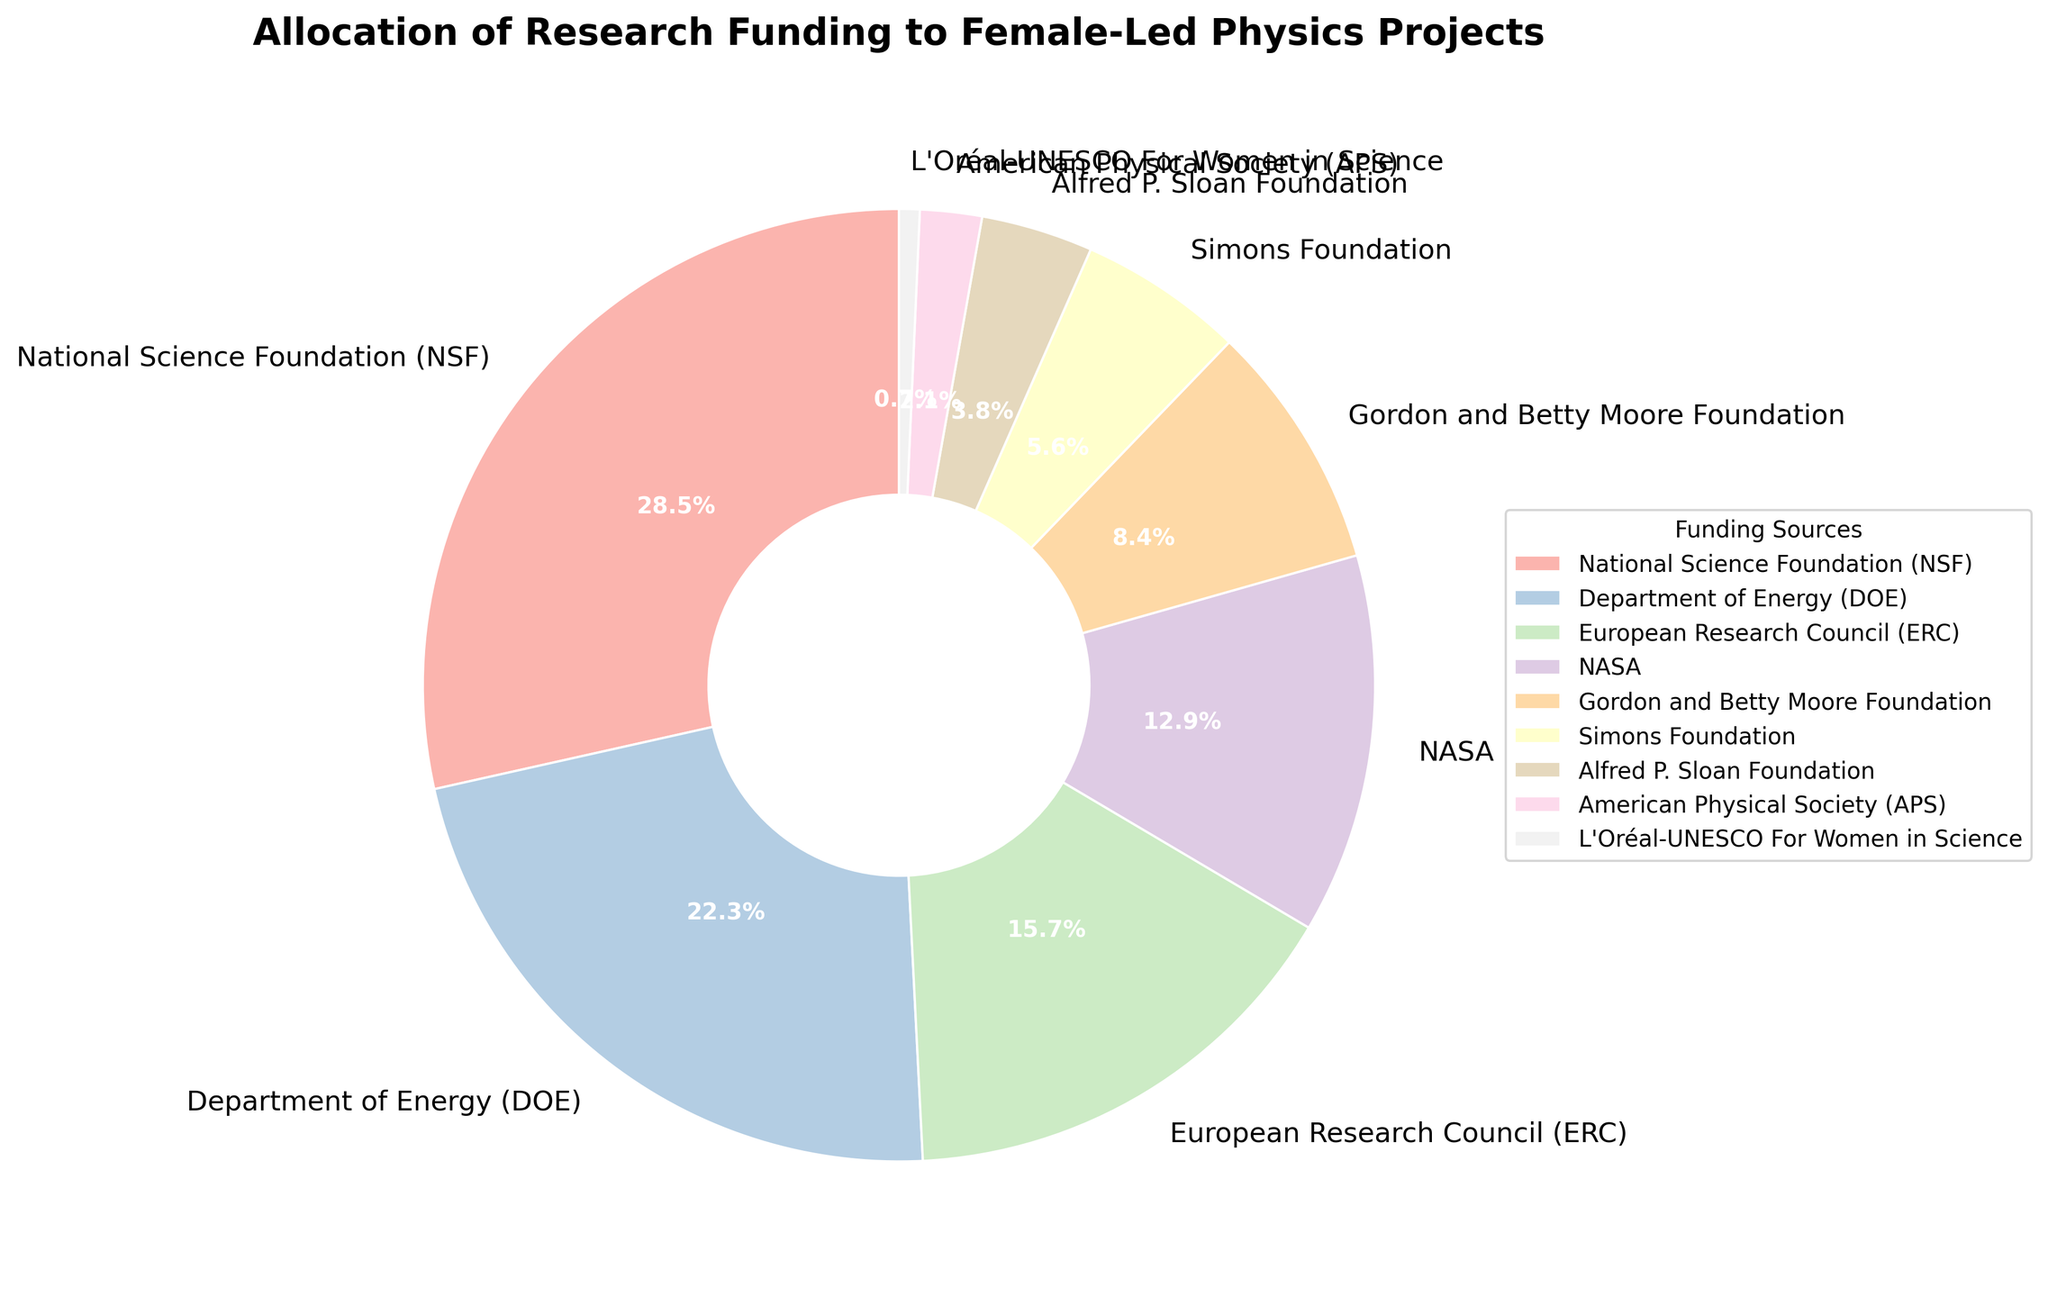What's the largest funding source for female-led physics projects? Look at the percentages on the pie chart and find the one with the highest value. NSF has the highest percentage at 28.5%.
Answer: NSF Which funding source contributes the smallest percentage to female-led physics projects? Identify the label in the pie chart with the smallest percentage value. L'Oréal-UNESCO For Women in Science has the smallest percentage at 0.7%.
Answer: L'Oréal-UNESCO For Women in Science What's the combined percentage of funding from NSF and DOE? Find the percentages for NSF and DOE in the pie chart and add them together. NSF is 28.5% and DOE is 22.3%, so 28.5% + 22.3% = 50.8%.
Answer: 50.8% Which funding sources together make up more than 40% of the total funding? Identify labels whose percentages sum to more than 40%. Both NSF (28.5%) and DOE (22.3%) together make 50.8%, which is greater than 40%.
Answer: NSF and DOE How does the funding from NASA compare to that from the European Research Council (ERC)? Find the percentages for NASA and ERC in the pie chart and compare them. NASA has 12.9%, and ERC has 15.7%. ERC contributes more than NASA.
Answer: ERC has more Which funding source contributes almost one-third of the total funding? Identify the label with a percentage close to one-third (approximately 33.3%) of the total. No single funding source reaches one-third of the total funding; NSF at 28.5% is the closest, but not quite one-third.
Answer: None What's the difference in funding percentage between the Gordon and Betty Moore Foundation and the Simons Foundation? Find the percentages for these foundations in the pie chart and subtract the smaller from the larger. Gordon and Betty Moore Foundation is 8.4%, and Simons Foundation is 5.6%, so 8.4% - 5.6% = 2.8%.
Answer: 2.8% What is the sum of all the funding percentages from private foundations listed? Find the percentages for private foundations (Gordon and Betty Moore Foundation, Simons Foundation, Alfred P. Sloan Foundation, L'Oréal-UNESCO For Women in Science) and add them together. 8.4% + 5.6% + 3.8% + 0.7% = 18.5%.
Answer: 18.5% How does the funding from the American Physical Society (APS) compare to that from the Alfred P. Sloan Foundation? Find the percentages for APS and Alfred P. Sloan Foundation in the pie chart and compare them. APS has 2.1%, and Alfred P. Sloan Foundation has 3.8%. Alfred P. Sloan Foundation contributes more than APS.
Answer: Alfred P. Sloan Foundation has more 